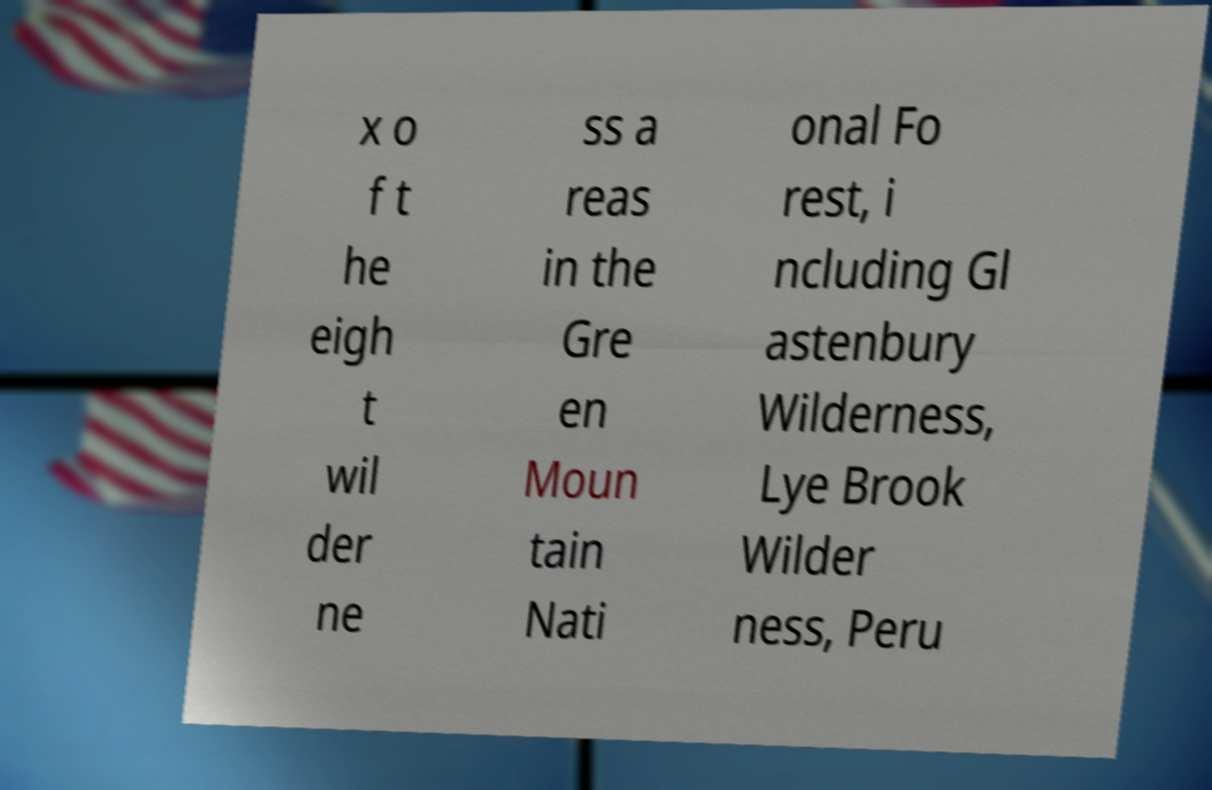Please identify and transcribe the text found in this image. x o f t he eigh t wil der ne ss a reas in the Gre en Moun tain Nati onal Fo rest, i ncluding Gl astenbury Wilderness, Lye Brook Wilder ness, Peru 